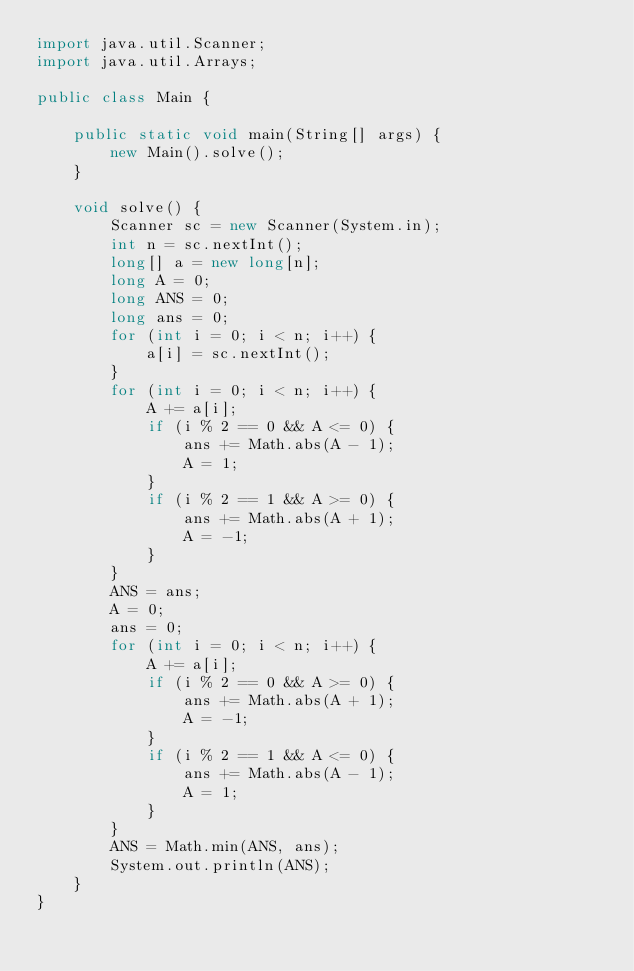<code> <loc_0><loc_0><loc_500><loc_500><_Java_>import java.util.Scanner;
import java.util.Arrays;

public class Main {

    public static void main(String[] args) {
        new Main().solve();
    }

    void solve() {
        Scanner sc = new Scanner(System.in);
        int n = sc.nextInt();
        long[] a = new long[n];
        long A = 0;
        long ANS = 0;
        long ans = 0;
        for (int i = 0; i < n; i++) {
            a[i] = sc.nextInt();
        }
        for (int i = 0; i < n; i++) {
            A += a[i];
            if (i % 2 == 0 && A <= 0) {
                ans += Math.abs(A - 1);
                A = 1;
            }
            if (i % 2 == 1 && A >= 0) {
                ans += Math.abs(A + 1);
                A = -1;
            }
        }
        ANS = ans;
        A = 0;
        ans = 0;
        for (int i = 0; i < n; i++) {
            A += a[i];
            if (i % 2 == 0 && A >= 0) {
                ans += Math.abs(A + 1);
                A = -1;
            }
            if (i % 2 == 1 && A <= 0) {
                ans += Math.abs(A - 1);
                A = 1;
            }
        }
        ANS = Math.min(ANS, ans);
        System.out.println(ANS);
    }
}
</code> 